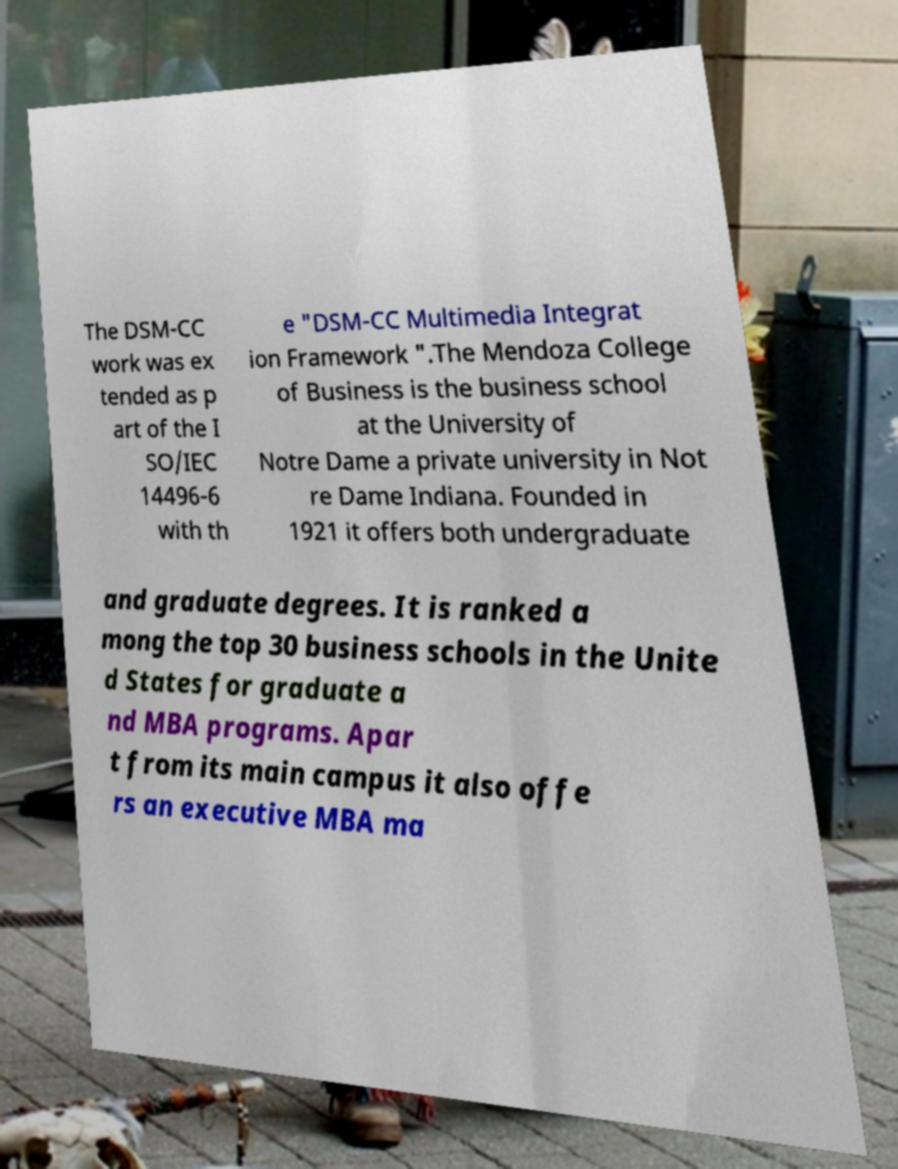Please read and relay the text visible in this image. What does it say? The DSM-CC work was ex tended as p art of the I SO/IEC 14496-6 with th e "DSM-CC Multimedia Integrat ion Framework ".The Mendoza College of Business is the business school at the University of Notre Dame a private university in Not re Dame Indiana. Founded in 1921 it offers both undergraduate and graduate degrees. It is ranked a mong the top 30 business schools in the Unite d States for graduate a nd MBA programs. Apar t from its main campus it also offe rs an executive MBA ma 